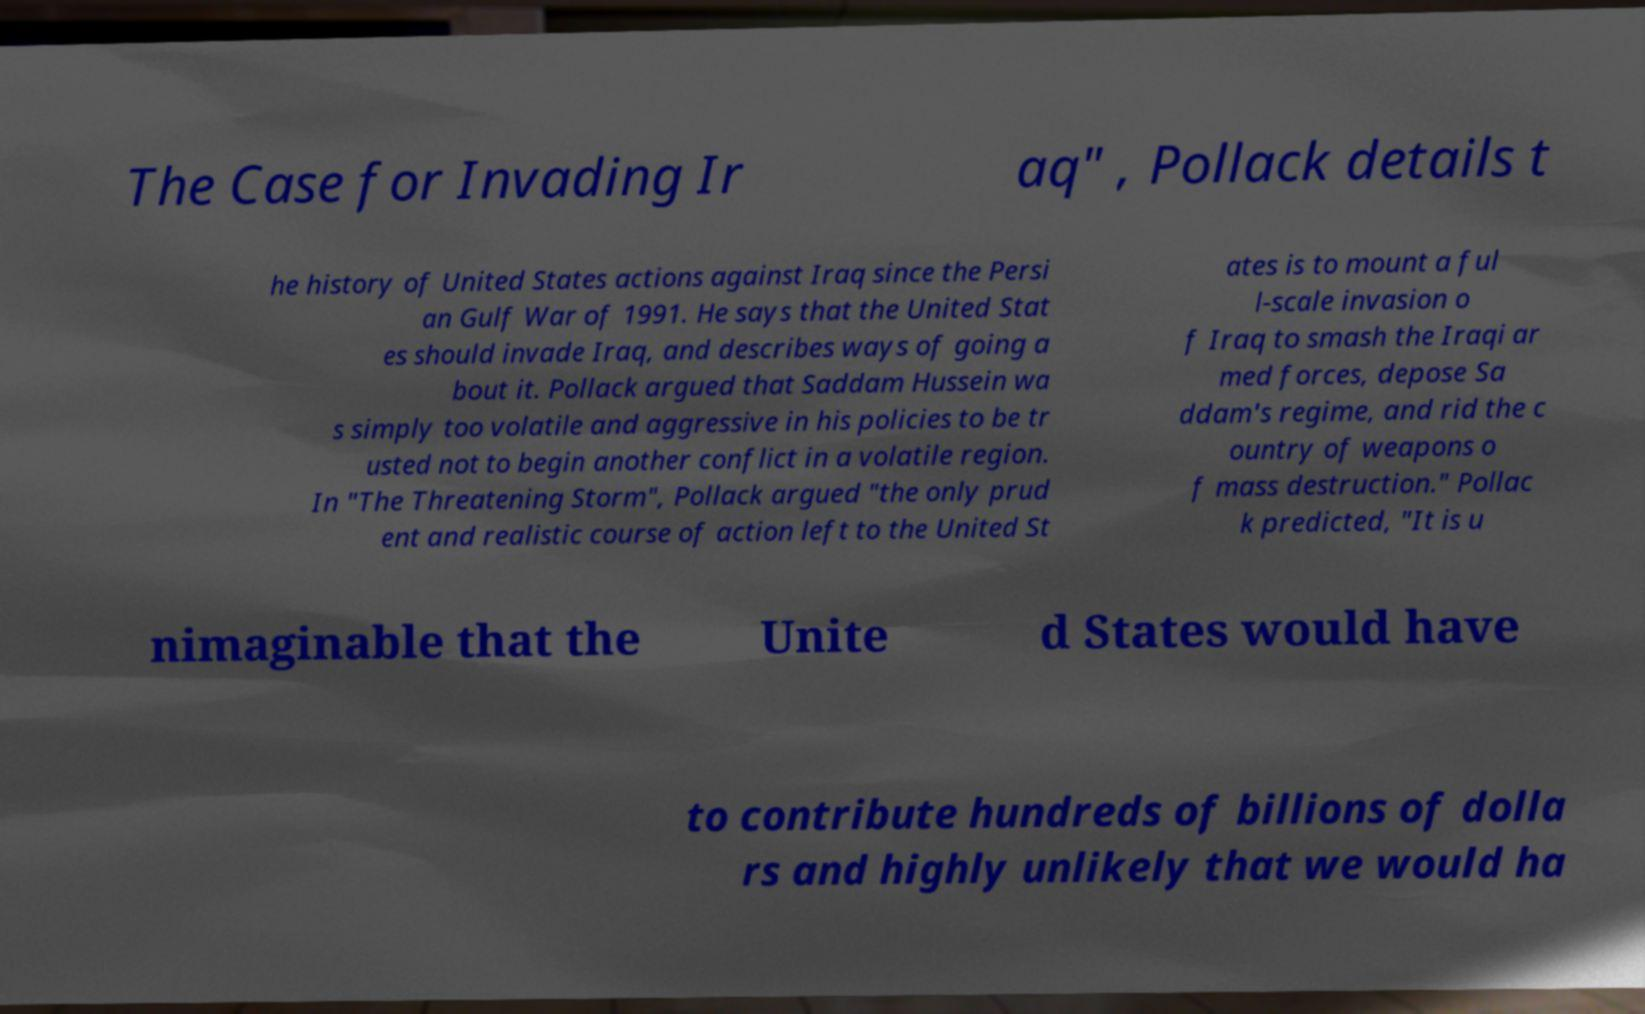Can you accurately transcribe the text from the provided image for me? The Case for Invading Ir aq" , Pollack details t he history of United States actions against Iraq since the Persi an Gulf War of 1991. He says that the United Stat es should invade Iraq, and describes ways of going a bout it. Pollack argued that Saddam Hussein wa s simply too volatile and aggressive in his policies to be tr usted not to begin another conflict in a volatile region. In "The Threatening Storm", Pollack argued "the only prud ent and realistic course of action left to the United St ates is to mount a ful l-scale invasion o f Iraq to smash the Iraqi ar med forces, depose Sa ddam's regime, and rid the c ountry of weapons o f mass destruction." Pollac k predicted, "It is u nimaginable that the Unite d States would have to contribute hundreds of billions of dolla rs and highly unlikely that we would ha 